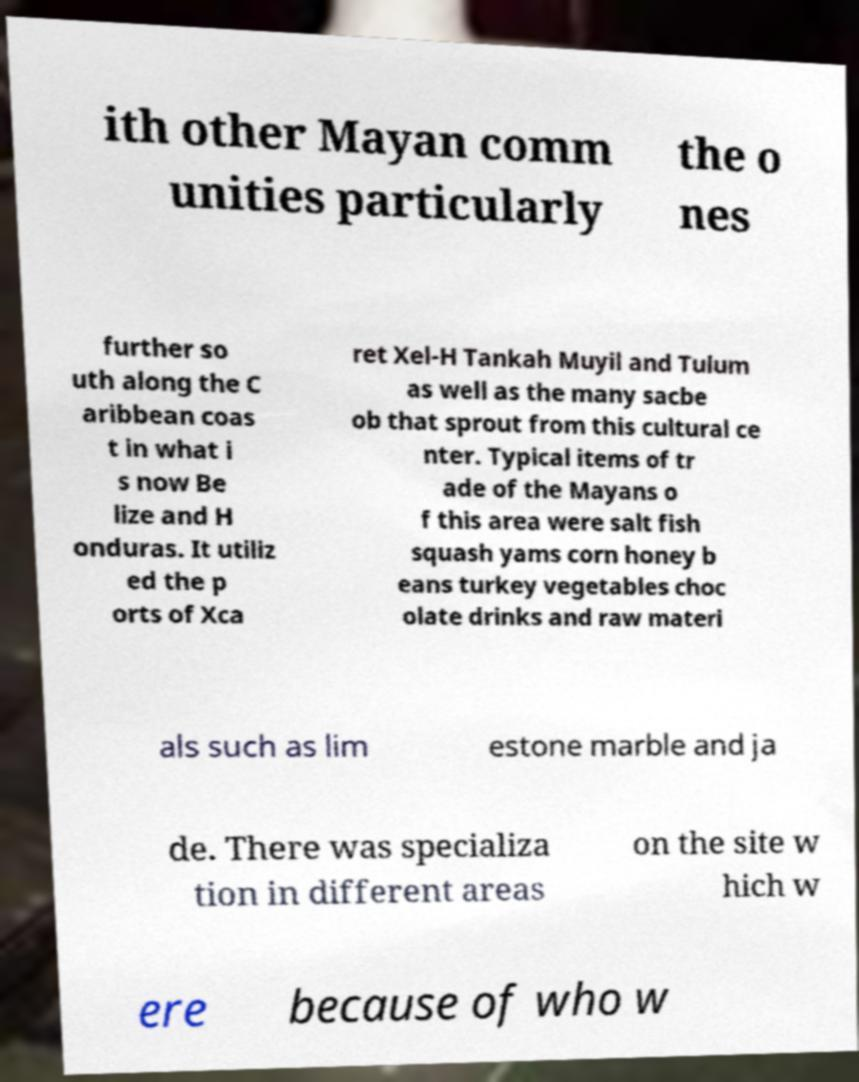Could you extract and type out the text from this image? ith other Mayan comm unities particularly the o nes further so uth along the C aribbean coas t in what i s now Be lize and H onduras. It utiliz ed the p orts of Xca ret Xel-H Tankah Muyil and Tulum as well as the many sacbe ob that sprout from this cultural ce nter. Typical items of tr ade of the Mayans o f this area were salt fish squash yams corn honey b eans turkey vegetables choc olate drinks and raw materi als such as lim estone marble and ja de. There was specializa tion in different areas on the site w hich w ere because of who w 